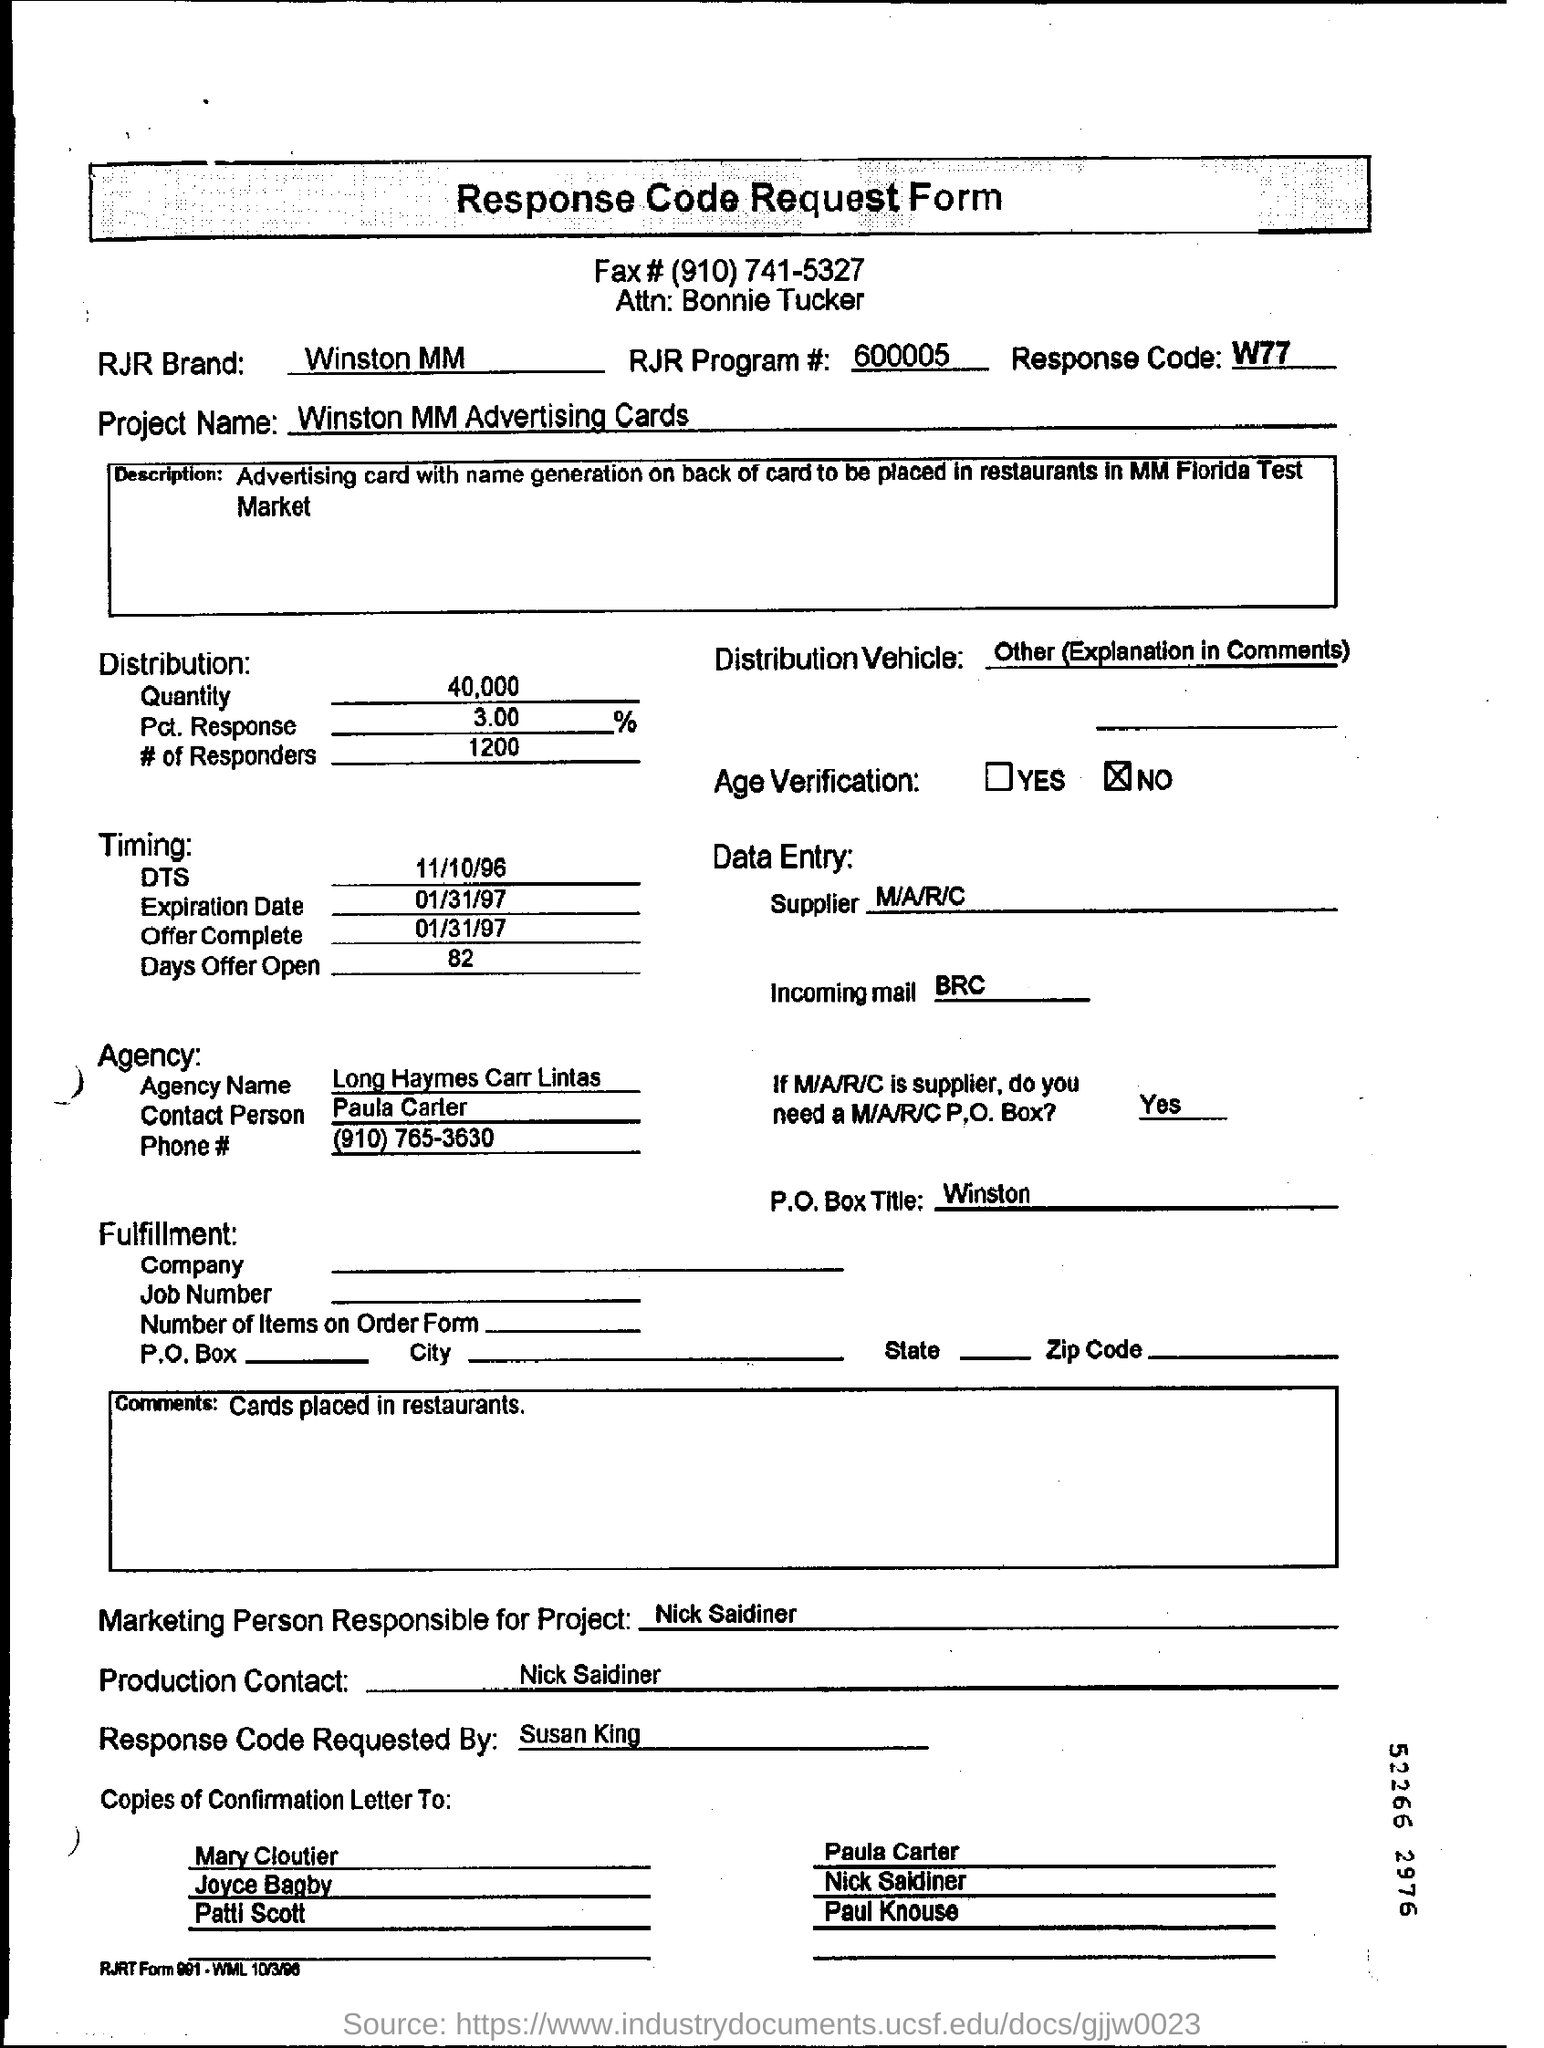What is the response code?
Ensure brevity in your answer.  W77. What is the date of expiration?
Give a very brief answer. 01/31/97. What is the name of project?
Ensure brevity in your answer.  Winston MM Advertising Cards. Who is the person for the production contact?
Provide a short and direct response. Nick Saidiner. 